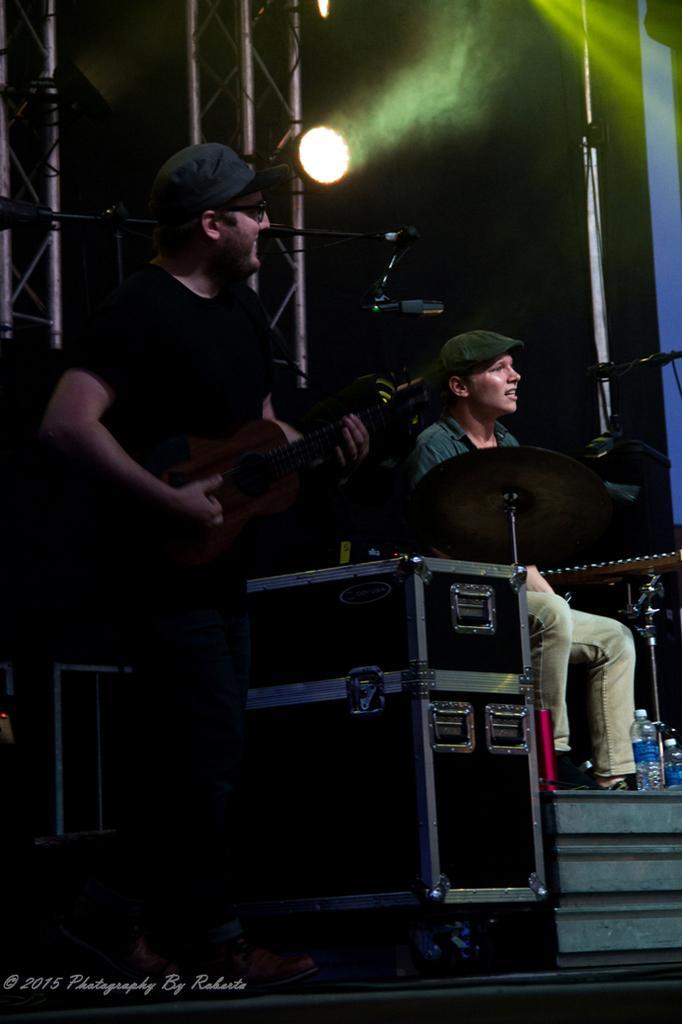Please provide a concise description of this image. There are two persons holding guitars and performing on the stage as we can see in the middle of this image. We can see metal objects on the left side of this image. There is a watermark at the bottom of this image. 